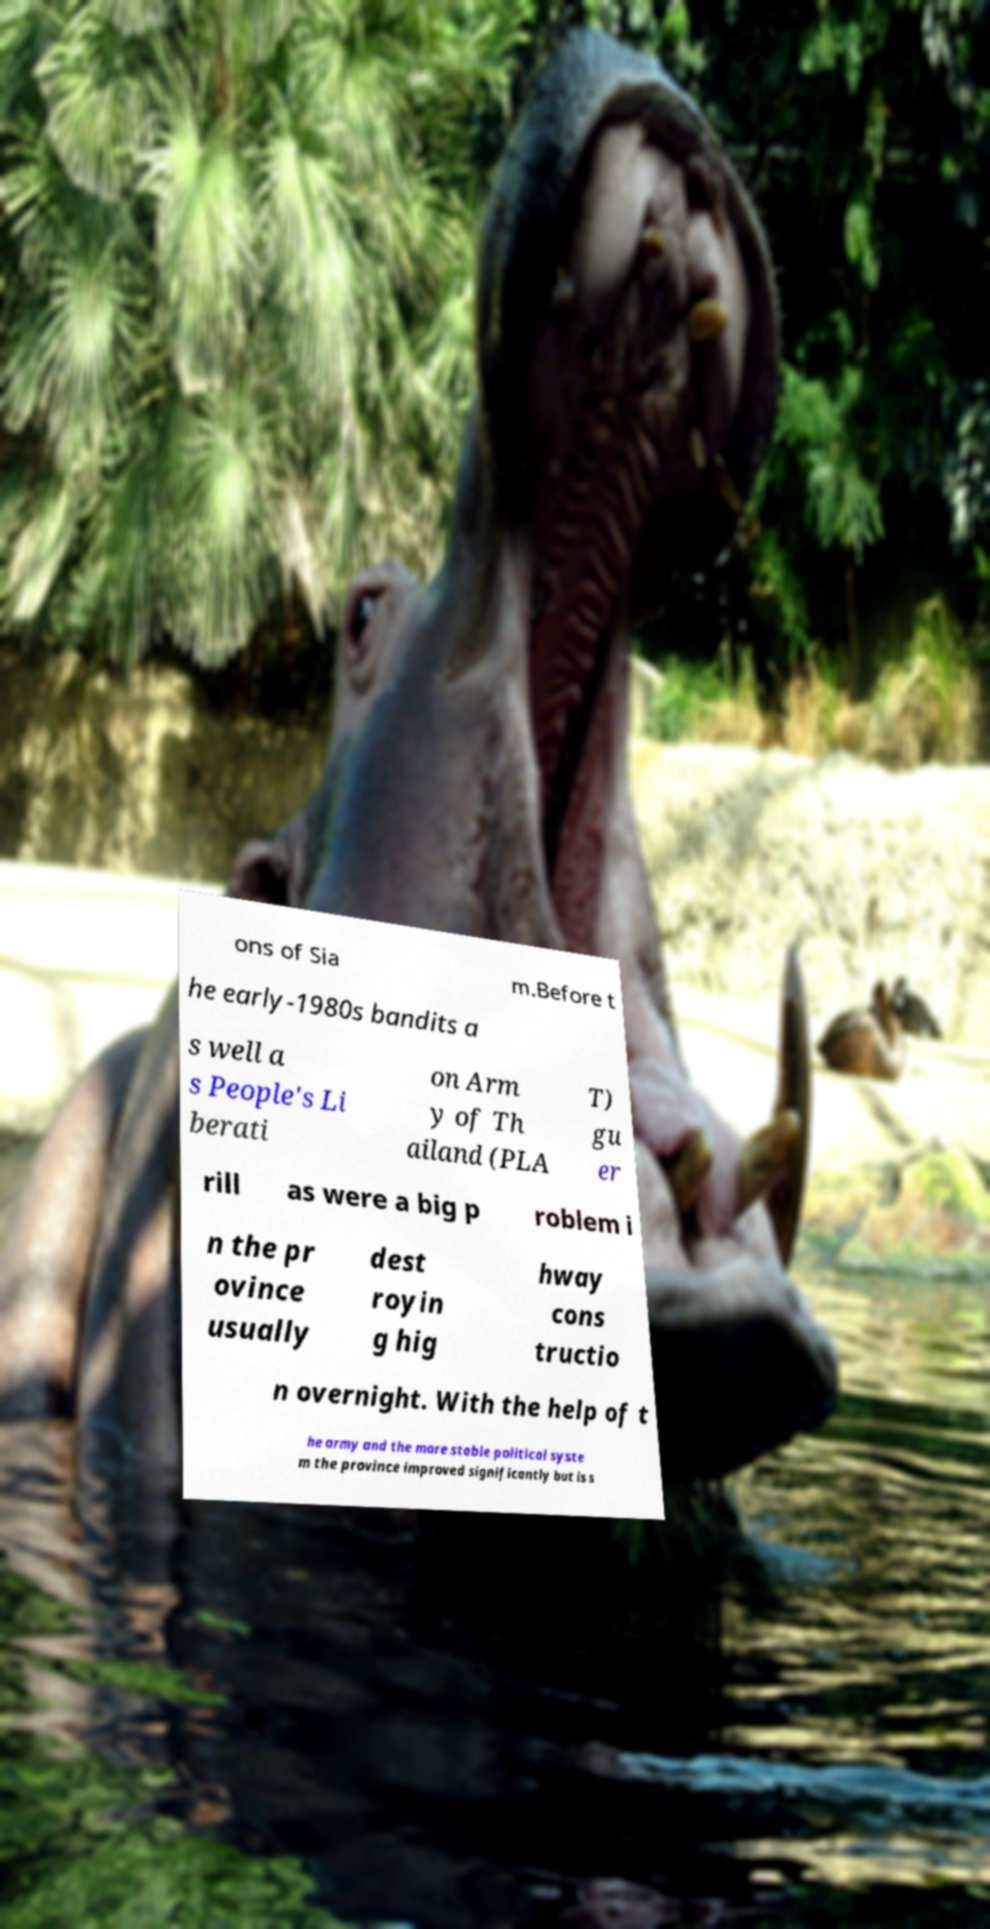I need the written content from this picture converted into text. Can you do that? ons of Sia m.Before t he early-1980s bandits a s well a s People's Li berati on Arm y of Th ailand (PLA T) gu er rill as were a big p roblem i n the pr ovince usually dest royin g hig hway cons tructio n overnight. With the help of t he army and the more stable political syste m the province improved significantly but is s 